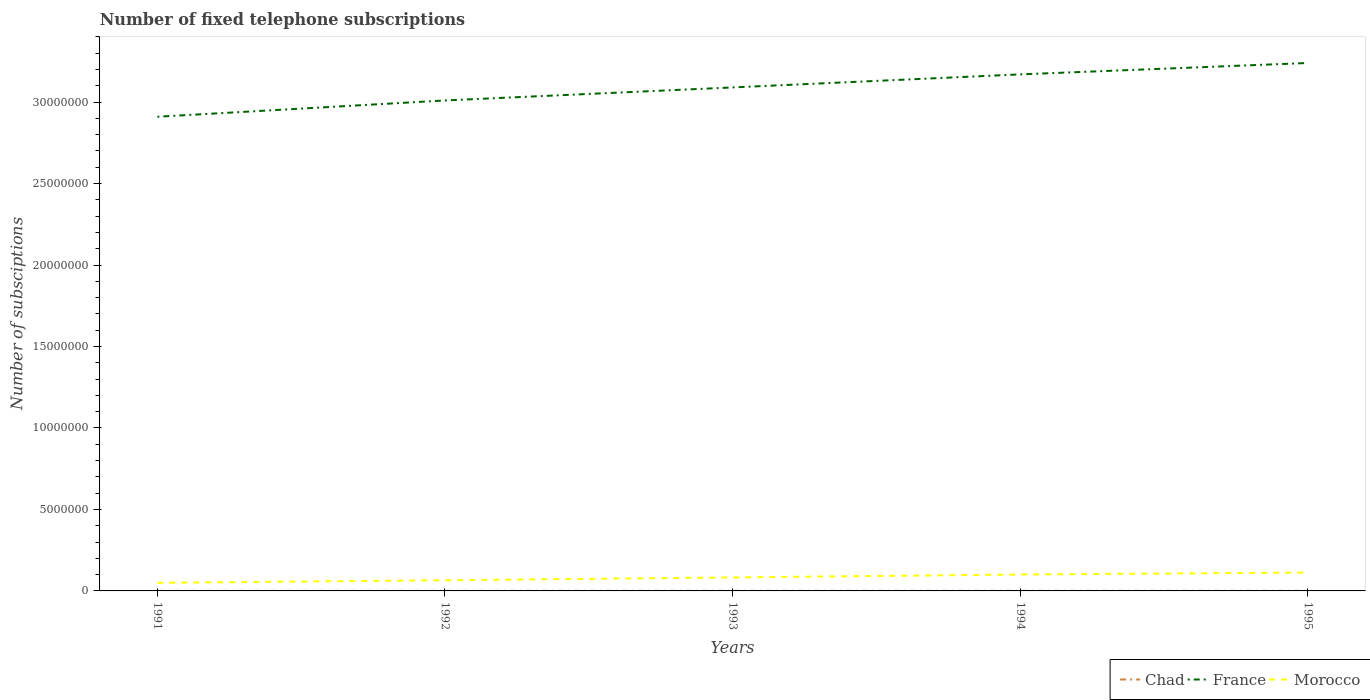How many different coloured lines are there?
Provide a succinct answer. 3. Across all years, what is the maximum number of fixed telephone subscriptions in Chad?
Keep it short and to the point. 4121. What is the total number of fixed telephone subscriptions in Morocco in the graph?
Provide a short and direct response. -1.80e+05. What is the difference between the highest and the second highest number of fixed telephone subscriptions in Chad?
Ensure brevity in your answer.  1213. What is the difference between the highest and the lowest number of fixed telephone subscriptions in France?
Offer a terse response. 3. Is the number of fixed telephone subscriptions in Chad strictly greater than the number of fixed telephone subscriptions in France over the years?
Provide a succinct answer. Yes. How many lines are there?
Give a very brief answer. 3. How many years are there in the graph?
Your response must be concise. 5. What is the difference between two consecutive major ticks on the Y-axis?
Your answer should be compact. 5.00e+06. Are the values on the major ticks of Y-axis written in scientific E-notation?
Keep it short and to the point. No. Does the graph contain any zero values?
Your answer should be very brief. No. How are the legend labels stacked?
Ensure brevity in your answer.  Horizontal. What is the title of the graph?
Keep it short and to the point. Number of fixed telephone subscriptions. Does "Guam" appear as one of the legend labels in the graph?
Provide a succinct answer. No. What is the label or title of the X-axis?
Provide a succinct answer. Years. What is the label or title of the Y-axis?
Make the answer very short. Number of subsciptions. What is the Number of subsciptions in Chad in 1991?
Keep it short and to the point. 4121. What is the Number of subsciptions in France in 1991?
Your response must be concise. 2.91e+07. What is the Number of subsciptions in Morocco in 1991?
Provide a succinct answer. 4.97e+05. What is the Number of subsciptions in Chad in 1992?
Ensure brevity in your answer.  4200. What is the Number of subsciptions of France in 1992?
Keep it short and to the point. 3.01e+07. What is the Number of subsciptions of Morocco in 1992?
Provide a short and direct response. 6.54e+05. What is the Number of subsciptions in Chad in 1993?
Give a very brief answer. 4571. What is the Number of subsciptions in France in 1993?
Make the answer very short. 3.09e+07. What is the Number of subsciptions in Morocco in 1993?
Provide a short and direct response. 8.27e+05. What is the Number of subsciptions of Chad in 1994?
Your answer should be compact. 4733. What is the Number of subsciptions of France in 1994?
Ensure brevity in your answer.  3.17e+07. What is the Number of subsciptions of Morocco in 1994?
Your answer should be very brief. 1.01e+06. What is the Number of subsciptions in Chad in 1995?
Provide a short and direct response. 5334. What is the Number of subsciptions of France in 1995?
Provide a short and direct response. 3.24e+07. What is the Number of subsciptions in Morocco in 1995?
Provide a succinct answer. 1.13e+06. Across all years, what is the maximum Number of subsciptions of Chad?
Provide a succinct answer. 5334. Across all years, what is the maximum Number of subsciptions of France?
Offer a terse response. 3.24e+07. Across all years, what is the maximum Number of subsciptions of Morocco?
Provide a short and direct response. 1.13e+06. Across all years, what is the minimum Number of subsciptions in Chad?
Keep it short and to the point. 4121. Across all years, what is the minimum Number of subsciptions in France?
Ensure brevity in your answer.  2.91e+07. Across all years, what is the minimum Number of subsciptions of Morocco?
Provide a short and direct response. 4.97e+05. What is the total Number of subsciptions of Chad in the graph?
Ensure brevity in your answer.  2.30e+04. What is the total Number of subsciptions in France in the graph?
Provide a short and direct response. 1.54e+08. What is the total Number of subsciptions in Morocco in the graph?
Your answer should be compact. 4.11e+06. What is the difference between the Number of subsciptions in Chad in 1991 and that in 1992?
Provide a succinct answer. -79. What is the difference between the Number of subsciptions in Morocco in 1991 and that in 1992?
Your answer should be very brief. -1.57e+05. What is the difference between the Number of subsciptions of Chad in 1991 and that in 1993?
Give a very brief answer. -450. What is the difference between the Number of subsciptions in France in 1991 and that in 1993?
Your answer should be compact. -1.80e+06. What is the difference between the Number of subsciptions of Morocco in 1991 and that in 1993?
Your answer should be very brief. -3.30e+05. What is the difference between the Number of subsciptions in Chad in 1991 and that in 1994?
Your answer should be very brief. -612. What is the difference between the Number of subsciptions in France in 1991 and that in 1994?
Your answer should be very brief. -2.60e+06. What is the difference between the Number of subsciptions of Morocco in 1991 and that in 1994?
Provide a short and direct response. -5.10e+05. What is the difference between the Number of subsciptions in Chad in 1991 and that in 1995?
Provide a short and direct response. -1213. What is the difference between the Number of subsciptions in France in 1991 and that in 1995?
Keep it short and to the point. -3.30e+06. What is the difference between the Number of subsciptions in Morocco in 1991 and that in 1995?
Your answer should be compact. -6.31e+05. What is the difference between the Number of subsciptions in Chad in 1992 and that in 1993?
Give a very brief answer. -371. What is the difference between the Number of subsciptions in France in 1992 and that in 1993?
Offer a terse response. -8.00e+05. What is the difference between the Number of subsciptions of Morocco in 1992 and that in 1993?
Give a very brief answer. -1.73e+05. What is the difference between the Number of subsciptions of Chad in 1992 and that in 1994?
Make the answer very short. -533. What is the difference between the Number of subsciptions in France in 1992 and that in 1994?
Give a very brief answer. -1.60e+06. What is the difference between the Number of subsciptions in Morocco in 1992 and that in 1994?
Your answer should be very brief. -3.53e+05. What is the difference between the Number of subsciptions of Chad in 1992 and that in 1995?
Keep it short and to the point. -1134. What is the difference between the Number of subsciptions of France in 1992 and that in 1995?
Keep it short and to the point. -2.30e+06. What is the difference between the Number of subsciptions in Morocco in 1992 and that in 1995?
Your answer should be compact. -4.74e+05. What is the difference between the Number of subsciptions of Chad in 1993 and that in 1994?
Offer a terse response. -162. What is the difference between the Number of subsciptions in France in 1993 and that in 1994?
Your answer should be compact. -8.00e+05. What is the difference between the Number of subsciptions of Morocco in 1993 and that in 1994?
Offer a very short reply. -1.80e+05. What is the difference between the Number of subsciptions of Chad in 1993 and that in 1995?
Provide a succinct answer. -763. What is the difference between the Number of subsciptions of France in 1993 and that in 1995?
Give a very brief answer. -1.50e+06. What is the difference between the Number of subsciptions in Morocco in 1993 and that in 1995?
Provide a succinct answer. -3.01e+05. What is the difference between the Number of subsciptions in Chad in 1994 and that in 1995?
Give a very brief answer. -601. What is the difference between the Number of subsciptions in France in 1994 and that in 1995?
Keep it short and to the point. -7.00e+05. What is the difference between the Number of subsciptions of Morocco in 1994 and that in 1995?
Offer a terse response. -1.21e+05. What is the difference between the Number of subsciptions in Chad in 1991 and the Number of subsciptions in France in 1992?
Ensure brevity in your answer.  -3.01e+07. What is the difference between the Number of subsciptions in Chad in 1991 and the Number of subsciptions in Morocco in 1992?
Offer a very short reply. -6.50e+05. What is the difference between the Number of subsciptions in France in 1991 and the Number of subsciptions in Morocco in 1992?
Your response must be concise. 2.84e+07. What is the difference between the Number of subsciptions of Chad in 1991 and the Number of subsciptions of France in 1993?
Your response must be concise. -3.09e+07. What is the difference between the Number of subsciptions of Chad in 1991 and the Number of subsciptions of Morocco in 1993?
Keep it short and to the point. -8.23e+05. What is the difference between the Number of subsciptions in France in 1991 and the Number of subsciptions in Morocco in 1993?
Your answer should be very brief. 2.83e+07. What is the difference between the Number of subsciptions in Chad in 1991 and the Number of subsciptions in France in 1994?
Offer a very short reply. -3.17e+07. What is the difference between the Number of subsciptions in Chad in 1991 and the Number of subsciptions in Morocco in 1994?
Provide a short and direct response. -1.00e+06. What is the difference between the Number of subsciptions in France in 1991 and the Number of subsciptions in Morocco in 1994?
Offer a terse response. 2.81e+07. What is the difference between the Number of subsciptions of Chad in 1991 and the Number of subsciptions of France in 1995?
Make the answer very short. -3.24e+07. What is the difference between the Number of subsciptions in Chad in 1991 and the Number of subsciptions in Morocco in 1995?
Give a very brief answer. -1.12e+06. What is the difference between the Number of subsciptions in France in 1991 and the Number of subsciptions in Morocco in 1995?
Give a very brief answer. 2.80e+07. What is the difference between the Number of subsciptions of Chad in 1992 and the Number of subsciptions of France in 1993?
Your answer should be very brief. -3.09e+07. What is the difference between the Number of subsciptions in Chad in 1992 and the Number of subsciptions in Morocco in 1993?
Ensure brevity in your answer.  -8.23e+05. What is the difference between the Number of subsciptions in France in 1992 and the Number of subsciptions in Morocco in 1993?
Your answer should be compact. 2.93e+07. What is the difference between the Number of subsciptions of Chad in 1992 and the Number of subsciptions of France in 1994?
Your response must be concise. -3.17e+07. What is the difference between the Number of subsciptions in Chad in 1992 and the Number of subsciptions in Morocco in 1994?
Your answer should be compact. -1.00e+06. What is the difference between the Number of subsciptions in France in 1992 and the Number of subsciptions in Morocco in 1994?
Give a very brief answer. 2.91e+07. What is the difference between the Number of subsciptions in Chad in 1992 and the Number of subsciptions in France in 1995?
Make the answer very short. -3.24e+07. What is the difference between the Number of subsciptions of Chad in 1992 and the Number of subsciptions of Morocco in 1995?
Ensure brevity in your answer.  -1.12e+06. What is the difference between the Number of subsciptions of France in 1992 and the Number of subsciptions of Morocco in 1995?
Your response must be concise. 2.90e+07. What is the difference between the Number of subsciptions of Chad in 1993 and the Number of subsciptions of France in 1994?
Offer a terse response. -3.17e+07. What is the difference between the Number of subsciptions in Chad in 1993 and the Number of subsciptions in Morocco in 1994?
Provide a succinct answer. -1.00e+06. What is the difference between the Number of subsciptions of France in 1993 and the Number of subsciptions of Morocco in 1994?
Offer a very short reply. 2.99e+07. What is the difference between the Number of subsciptions in Chad in 1993 and the Number of subsciptions in France in 1995?
Your answer should be compact. -3.24e+07. What is the difference between the Number of subsciptions in Chad in 1993 and the Number of subsciptions in Morocco in 1995?
Give a very brief answer. -1.12e+06. What is the difference between the Number of subsciptions in France in 1993 and the Number of subsciptions in Morocco in 1995?
Your answer should be very brief. 2.98e+07. What is the difference between the Number of subsciptions of Chad in 1994 and the Number of subsciptions of France in 1995?
Ensure brevity in your answer.  -3.24e+07. What is the difference between the Number of subsciptions of Chad in 1994 and the Number of subsciptions of Morocco in 1995?
Make the answer very short. -1.12e+06. What is the difference between the Number of subsciptions of France in 1994 and the Number of subsciptions of Morocco in 1995?
Provide a short and direct response. 3.06e+07. What is the average Number of subsciptions in Chad per year?
Make the answer very short. 4591.8. What is the average Number of subsciptions of France per year?
Keep it short and to the point. 3.08e+07. What is the average Number of subsciptions in Morocco per year?
Offer a very short reply. 8.23e+05. In the year 1991, what is the difference between the Number of subsciptions of Chad and Number of subsciptions of France?
Give a very brief answer. -2.91e+07. In the year 1991, what is the difference between the Number of subsciptions in Chad and Number of subsciptions in Morocco?
Your answer should be compact. -4.93e+05. In the year 1991, what is the difference between the Number of subsciptions in France and Number of subsciptions in Morocco?
Offer a very short reply. 2.86e+07. In the year 1992, what is the difference between the Number of subsciptions in Chad and Number of subsciptions in France?
Your response must be concise. -3.01e+07. In the year 1992, what is the difference between the Number of subsciptions in Chad and Number of subsciptions in Morocco?
Ensure brevity in your answer.  -6.50e+05. In the year 1992, what is the difference between the Number of subsciptions in France and Number of subsciptions in Morocco?
Offer a terse response. 2.94e+07. In the year 1993, what is the difference between the Number of subsciptions of Chad and Number of subsciptions of France?
Offer a very short reply. -3.09e+07. In the year 1993, what is the difference between the Number of subsciptions in Chad and Number of subsciptions in Morocco?
Make the answer very short. -8.22e+05. In the year 1993, what is the difference between the Number of subsciptions in France and Number of subsciptions in Morocco?
Give a very brief answer. 3.01e+07. In the year 1994, what is the difference between the Number of subsciptions in Chad and Number of subsciptions in France?
Ensure brevity in your answer.  -3.17e+07. In the year 1994, what is the difference between the Number of subsciptions of Chad and Number of subsciptions of Morocco?
Your response must be concise. -1.00e+06. In the year 1994, what is the difference between the Number of subsciptions of France and Number of subsciptions of Morocco?
Offer a terse response. 3.07e+07. In the year 1995, what is the difference between the Number of subsciptions of Chad and Number of subsciptions of France?
Your answer should be very brief. -3.24e+07. In the year 1995, what is the difference between the Number of subsciptions of Chad and Number of subsciptions of Morocco?
Offer a very short reply. -1.12e+06. In the year 1995, what is the difference between the Number of subsciptions of France and Number of subsciptions of Morocco?
Provide a succinct answer. 3.13e+07. What is the ratio of the Number of subsciptions of Chad in 1991 to that in 1992?
Your answer should be compact. 0.98. What is the ratio of the Number of subsciptions of France in 1991 to that in 1992?
Your response must be concise. 0.97. What is the ratio of the Number of subsciptions in Morocco in 1991 to that in 1992?
Ensure brevity in your answer.  0.76. What is the ratio of the Number of subsciptions in Chad in 1991 to that in 1993?
Ensure brevity in your answer.  0.9. What is the ratio of the Number of subsciptions of France in 1991 to that in 1993?
Offer a very short reply. 0.94. What is the ratio of the Number of subsciptions of Morocco in 1991 to that in 1993?
Provide a succinct answer. 0.6. What is the ratio of the Number of subsciptions of Chad in 1991 to that in 1994?
Offer a very short reply. 0.87. What is the ratio of the Number of subsciptions of France in 1991 to that in 1994?
Ensure brevity in your answer.  0.92. What is the ratio of the Number of subsciptions of Morocco in 1991 to that in 1994?
Make the answer very short. 0.49. What is the ratio of the Number of subsciptions in Chad in 1991 to that in 1995?
Make the answer very short. 0.77. What is the ratio of the Number of subsciptions of France in 1991 to that in 1995?
Offer a very short reply. 0.9. What is the ratio of the Number of subsciptions in Morocco in 1991 to that in 1995?
Your answer should be very brief. 0.44. What is the ratio of the Number of subsciptions in Chad in 1992 to that in 1993?
Ensure brevity in your answer.  0.92. What is the ratio of the Number of subsciptions in France in 1992 to that in 1993?
Keep it short and to the point. 0.97. What is the ratio of the Number of subsciptions of Morocco in 1992 to that in 1993?
Make the answer very short. 0.79. What is the ratio of the Number of subsciptions of Chad in 1992 to that in 1994?
Provide a short and direct response. 0.89. What is the ratio of the Number of subsciptions in France in 1992 to that in 1994?
Your answer should be compact. 0.95. What is the ratio of the Number of subsciptions in Morocco in 1992 to that in 1994?
Your answer should be very brief. 0.65. What is the ratio of the Number of subsciptions in Chad in 1992 to that in 1995?
Your answer should be very brief. 0.79. What is the ratio of the Number of subsciptions in France in 1992 to that in 1995?
Make the answer very short. 0.93. What is the ratio of the Number of subsciptions in Morocco in 1992 to that in 1995?
Offer a terse response. 0.58. What is the ratio of the Number of subsciptions of Chad in 1993 to that in 1994?
Give a very brief answer. 0.97. What is the ratio of the Number of subsciptions in France in 1993 to that in 1994?
Give a very brief answer. 0.97. What is the ratio of the Number of subsciptions of Morocco in 1993 to that in 1994?
Offer a terse response. 0.82. What is the ratio of the Number of subsciptions in Chad in 1993 to that in 1995?
Your answer should be compact. 0.86. What is the ratio of the Number of subsciptions in France in 1993 to that in 1995?
Offer a very short reply. 0.95. What is the ratio of the Number of subsciptions of Morocco in 1993 to that in 1995?
Your response must be concise. 0.73. What is the ratio of the Number of subsciptions of Chad in 1994 to that in 1995?
Give a very brief answer. 0.89. What is the ratio of the Number of subsciptions in France in 1994 to that in 1995?
Ensure brevity in your answer.  0.98. What is the ratio of the Number of subsciptions of Morocco in 1994 to that in 1995?
Ensure brevity in your answer.  0.89. What is the difference between the highest and the second highest Number of subsciptions of Chad?
Offer a terse response. 601. What is the difference between the highest and the second highest Number of subsciptions in Morocco?
Keep it short and to the point. 1.21e+05. What is the difference between the highest and the lowest Number of subsciptions in Chad?
Provide a short and direct response. 1213. What is the difference between the highest and the lowest Number of subsciptions of France?
Provide a succinct answer. 3.30e+06. What is the difference between the highest and the lowest Number of subsciptions of Morocco?
Provide a succinct answer. 6.31e+05. 